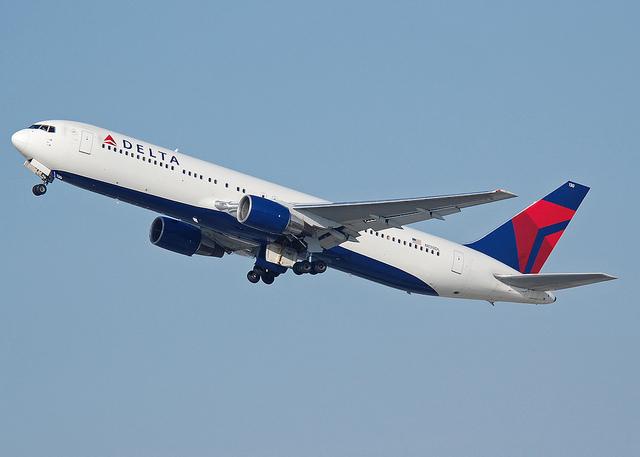What does the plane say?
Answer briefly. Delta. Is the plane close to a fence?
Give a very brief answer. No. What phase of the flight pattern is the jet in?
Keep it brief. Take off. What airlines is this?
Write a very short answer. Delta. What airline is this?
Quick response, please. Delta. What airline is this plane part of?
Concise answer only. Delta. Is this plane getting ready to land?
Concise answer only. No. What color is the sky?
Keep it brief. Blue. What is the name of the plane?
Write a very short answer. Delta. 